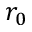Convert formula to latex. <formula><loc_0><loc_0><loc_500><loc_500>r _ { 0 }</formula> 